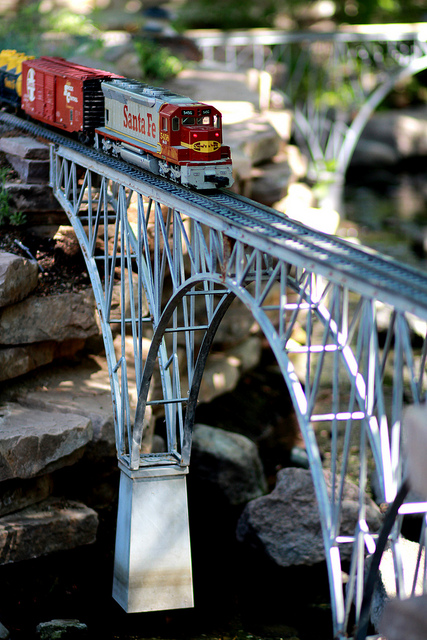Please extract the text content from this image. Santa Fe 